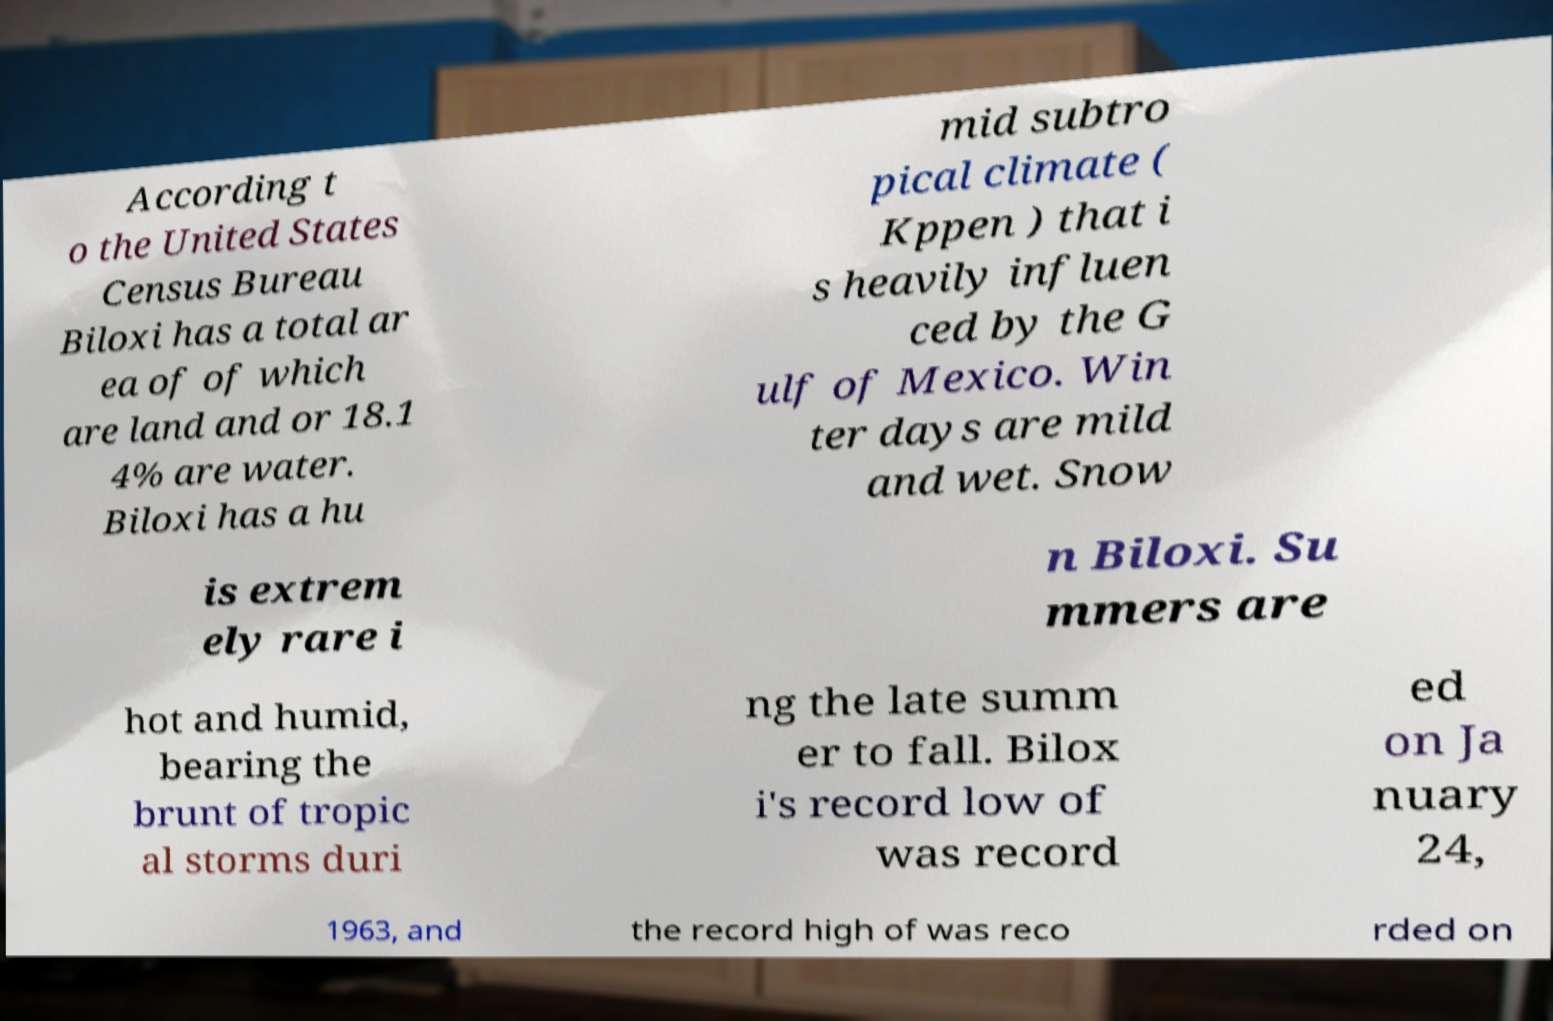There's text embedded in this image that I need extracted. Can you transcribe it verbatim? According t o the United States Census Bureau Biloxi has a total ar ea of of which are land and or 18.1 4% are water. Biloxi has a hu mid subtro pical climate ( Kppen ) that i s heavily influen ced by the G ulf of Mexico. Win ter days are mild and wet. Snow is extrem ely rare i n Biloxi. Su mmers are hot and humid, bearing the brunt of tropic al storms duri ng the late summ er to fall. Bilox i's record low of was record ed on Ja nuary 24, 1963, and the record high of was reco rded on 